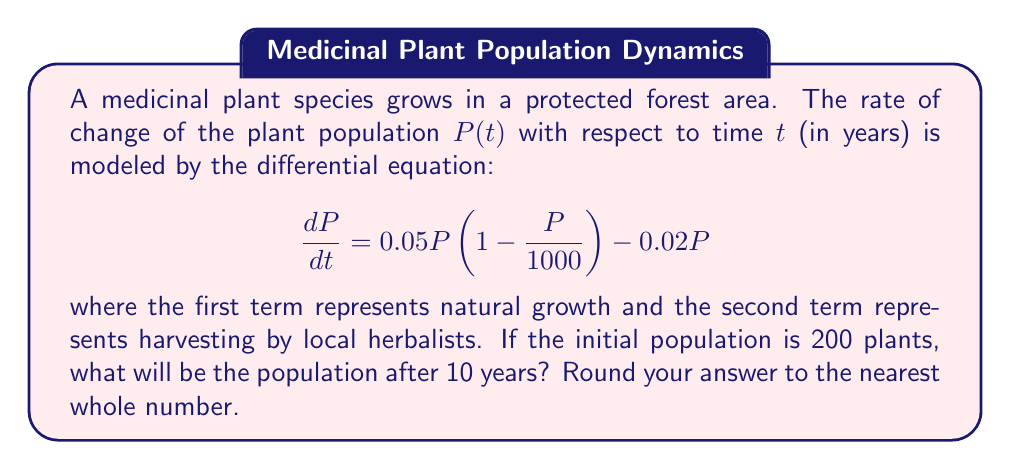What is the answer to this math problem? To solve this problem, we need to use the logistic growth model with harvesting. Let's approach this step-by-step:

1) The given differential equation is:

   $$\frac{dP}{dt} = 0.05P(1 - \frac{P}{1000}) - 0.02P$$

2) This can be rewritten as:

   $$\frac{dP}{dt} = 0.05P - 0.00005P^2 - 0.02P = 0.03P - 0.00005P^2$$

3) This is a separable differential equation. We can solve it using the following steps:

   $$\int \frac{dP}{0.03P - 0.00005P^2} = \int dt$$

4) The left-hand side can be solved using partial fractions:

   $$\int \frac{dP}{0.03P - 0.00005P^2} = -\frac{1}{600} \ln|0.03 - 0.00005P| + \frac{1}{600} \ln|P| + C$$

5) Solving the right-hand side:

   $$-\frac{1}{600} \ln|0.03 - 0.00005P| + \frac{1}{600} \ln|P| = t + C$$

6) Using the initial condition $P(0) = 200$, we can solve for $C$:

   $$C = -\frac{1}{600} \ln|0.03 - 0.00005(200)| + \frac{1}{600} \ln|200|$$

7) Now we can set up the equation for $P(10)$:

   $$-\frac{1}{600} \ln|0.03 - 0.00005P(10)| + \frac{1}{600} \ln|P(10)| = 10 + C$$

8) Substituting the value of $C$ and solving numerically (as this equation cannot be solved analytically), we get:

   $$P(10) \approx 442.86$$

9) Rounding to the nearest whole number:

   $$P(10) \approx 443$$
Answer: 443 plants 